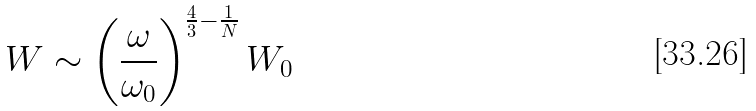<formula> <loc_0><loc_0><loc_500><loc_500>W \sim \left ( \frac { \omega } { \omega _ { 0 } } \right ) ^ { \frac { 4 } { 3 } - \frac { 1 } { N } } W _ { 0 }</formula> 